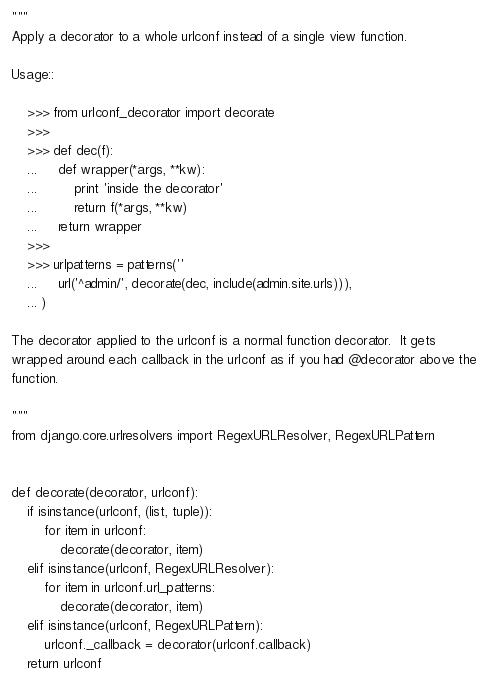Convert code to text. <code><loc_0><loc_0><loc_500><loc_500><_Python_>"""
Apply a decorator to a whole urlconf instead of a single view function.

Usage::

    >>> from urlconf_decorator import decorate
    >>>
    >>> def dec(f):
    ...     def wrapper(*args, **kw):
    ...         print 'inside the decorator'
    ...         return f(*args, **kw)
    ...     return wrapper
    >>>
    >>> urlpatterns = patterns(''
    ...     url('^admin/', decorate(dec, include(admin.site.urls))),
    ... )

The decorator applied to the urlconf is a normal function decorator.  It gets
wrapped around each callback in the urlconf as if you had @decorator above the
function.

"""
from django.core.urlresolvers import RegexURLResolver, RegexURLPattern


def decorate(decorator, urlconf):
    if isinstance(urlconf, (list, tuple)):
        for item in urlconf:
            decorate(decorator, item)
    elif isinstance(urlconf, RegexURLResolver):
        for item in urlconf.url_patterns:
            decorate(decorator, item)
    elif isinstance(urlconf, RegexURLPattern):
        urlconf._callback = decorator(urlconf.callback)
    return urlconf
</code> 